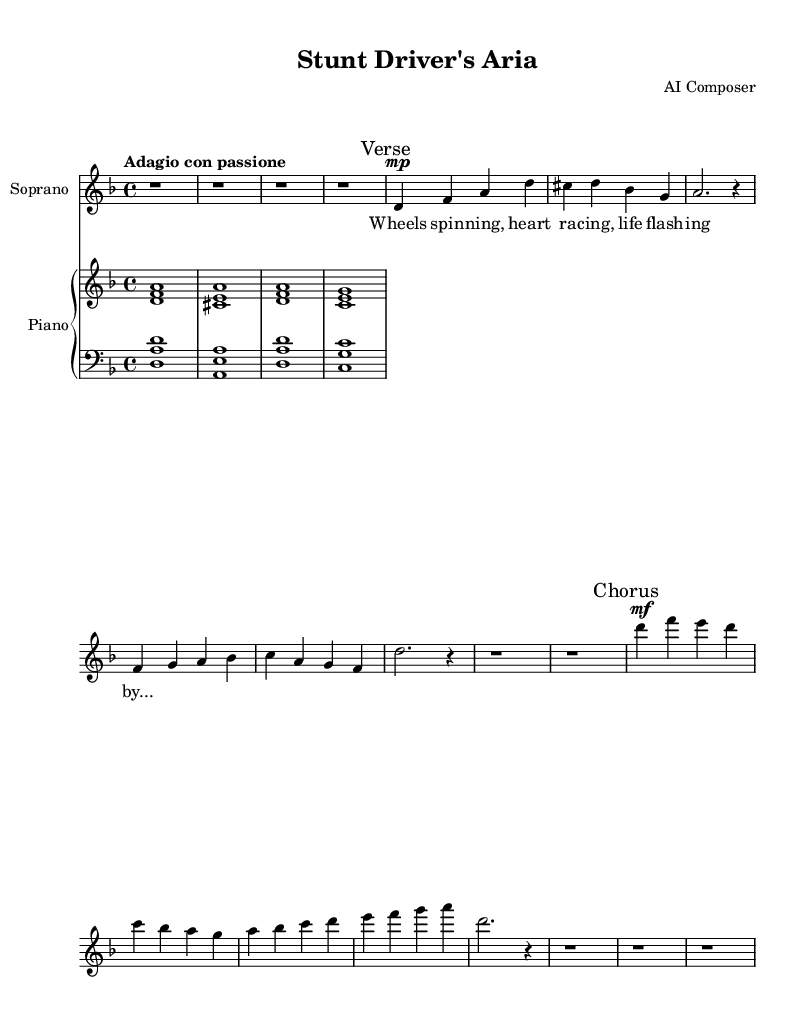What is the key signature of this music? The key signature is D minor, which has one flat (B flat). This is indicated at the beginning of the sheet music where the flat symbol is shown for the B note.
Answer: D minor What is the time signature of this music? The time signature is 4/4, which can be found at the beginning of the sheet music next to the key signature. It indicates there are four beats in each measure and a quarter note receives one beat.
Answer: 4/4 What is the tempo marking of this music? The tempo marking is "Adagio con passione," located at the beginning of the sheet music. "Adagio" implies a slow tempo, and "con passione" suggests playing with emotion, enhancing its expressive quality.
Answer: Adagio con passione How many measures are in the soprano part? By counting the number of measures in the soprano section, we can see there are a total of 8 measures in the provided music. Each set of notes separated by vertical bar lines represents a single measure.
Answer: 8 measures What is the dynamic marking for the chorus section? The dynamic marking is marked as "mf" (mezzo-forte) at the beginning of the chorus, indicating a medium loudness. This dynamic change is common in operatic arias to convey heightened emotion.
Answer: mf What type of accompaniment is used in the piano section? The accompaniment in the piano section is chordal, with the upper staff playing chords and the lower staff accompanying with bass notes, typical of Romantic opera to provide harmonic support.
Answer: Chordal What is the overarching theme captured in the lyrics of this aria? The overarching theme captured in the lyrics is about the thrill and intensity of life experiences, particularly in the context of speed and excitement as indicated by phrases like "Wheels spinning" and "life flashing by."
Answer: Thrill of life experiences 